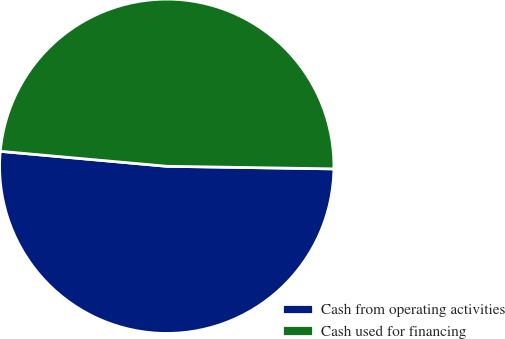<chart> <loc_0><loc_0><loc_500><loc_500><pie_chart><fcel>Cash from operating activities<fcel>Cash used for financing<nl><fcel>51.18%<fcel>48.82%<nl></chart> 